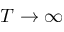<formula> <loc_0><loc_0><loc_500><loc_500>T \to \infty</formula> 